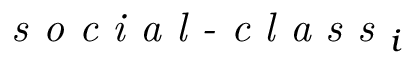Convert formula to latex. <formula><loc_0><loc_0><loc_500><loc_500>s o c i a l - c l a s s _ { i }</formula> 